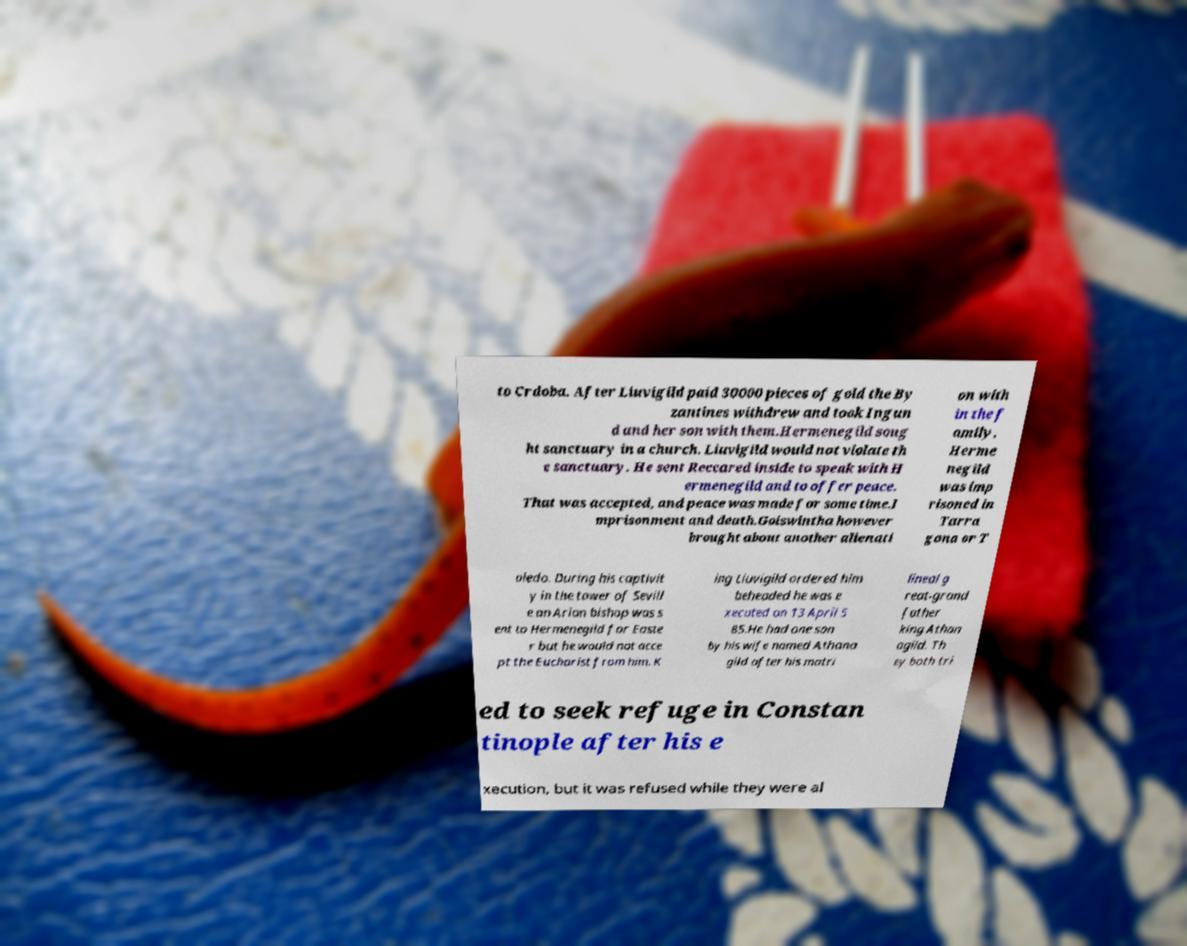Can you accurately transcribe the text from the provided image for me? to Crdoba. After Liuvigild paid 30000 pieces of gold the By zantines withdrew and took Ingun d and her son with them.Hermenegild soug ht sanctuary in a church. Liuvigild would not violate th e sanctuary. He sent Reccared inside to speak with H ermenegild and to offer peace. That was accepted, and peace was made for some time.I mprisonment and death.Goiswintha however brought about another alienati on with in the f amily. Herme negild was imp risoned in Tarra gona or T oledo. During his captivit y in the tower of Sevill e an Arian bishop was s ent to Hermenegild for Easte r but he would not acce pt the Eucharist from him. K ing Liuvigild ordered him beheaded he was e xecuted on 13 April 5 85.He had one son by his wife named Athana gild after his matri lineal g reat-grand father king Athan agild. Th ey both tri ed to seek refuge in Constan tinople after his e xecution, but it was refused while they were al 